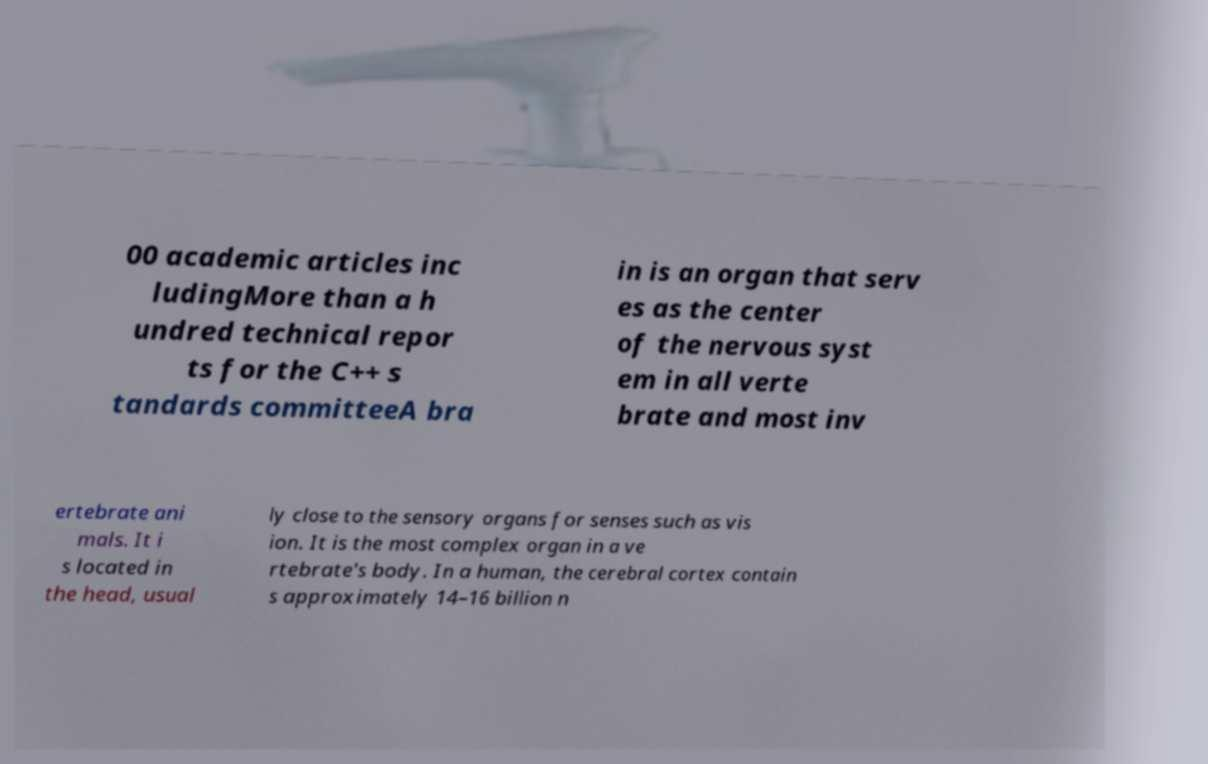Could you extract and type out the text from this image? 00 academic articles inc ludingMore than a h undred technical repor ts for the C++ s tandards committeeA bra in is an organ that serv es as the center of the nervous syst em in all verte brate and most inv ertebrate ani mals. It i s located in the head, usual ly close to the sensory organs for senses such as vis ion. It is the most complex organ in a ve rtebrate's body. In a human, the cerebral cortex contain s approximately 14–16 billion n 